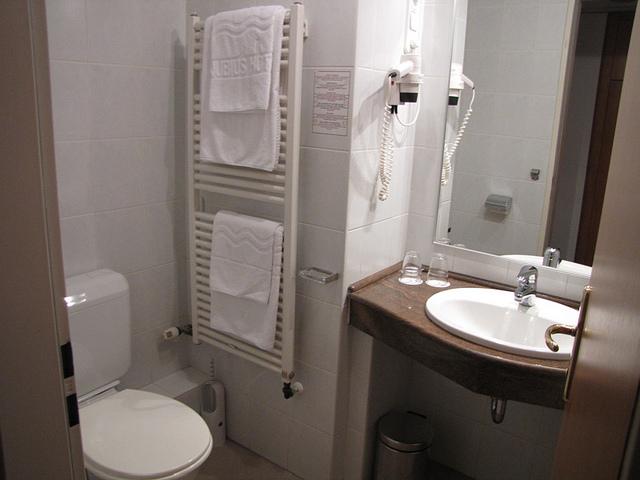What pattern of lines is near the top of the towels?
Write a very short answer. Wavy. How many sinks are in the picture?
Write a very short answer. 1. Is the toilet lid down or up?
Concise answer only. Down. Is the toilets lid up or down?
Keep it brief. Down. 